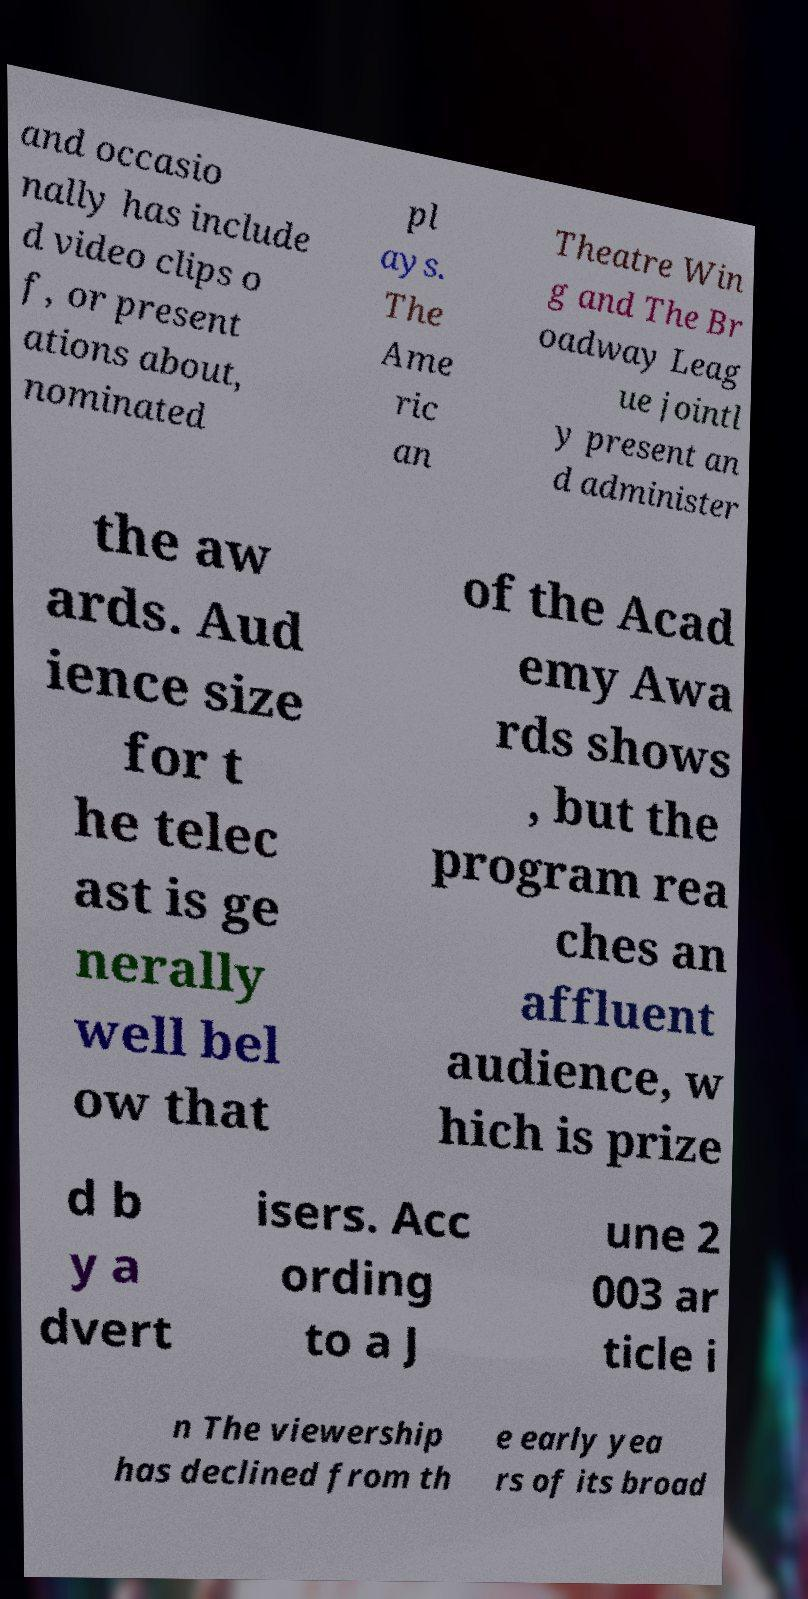For documentation purposes, I need the text within this image transcribed. Could you provide that? and occasio nally has include d video clips o f, or present ations about, nominated pl ays. The Ame ric an Theatre Win g and The Br oadway Leag ue jointl y present an d administer the aw ards. Aud ience size for t he telec ast is ge nerally well bel ow that of the Acad emy Awa rds shows , but the program rea ches an affluent audience, w hich is prize d b y a dvert isers. Acc ording to a J une 2 003 ar ticle i n The viewership has declined from th e early yea rs of its broad 